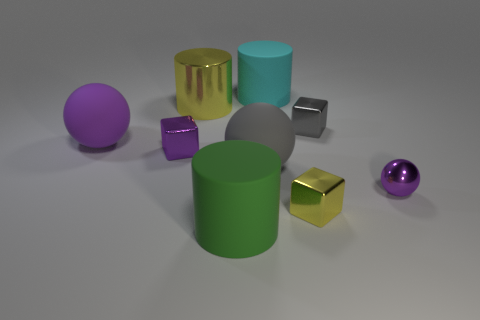Add 1 large blue rubber cylinders. How many objects exist? 10 Subtract all cylinders. How many objects are left? 6 Add 8 large green rubber cylinders. How many large green rubber cylinders exist? 9 Subtract 0 red spheres. How many objects are left? 9 Subtract all large yellow things. Subtract all large green rubber cylinders. How many objects are left? 7 Add 4 big gray things. How many big gray things are left? 5 